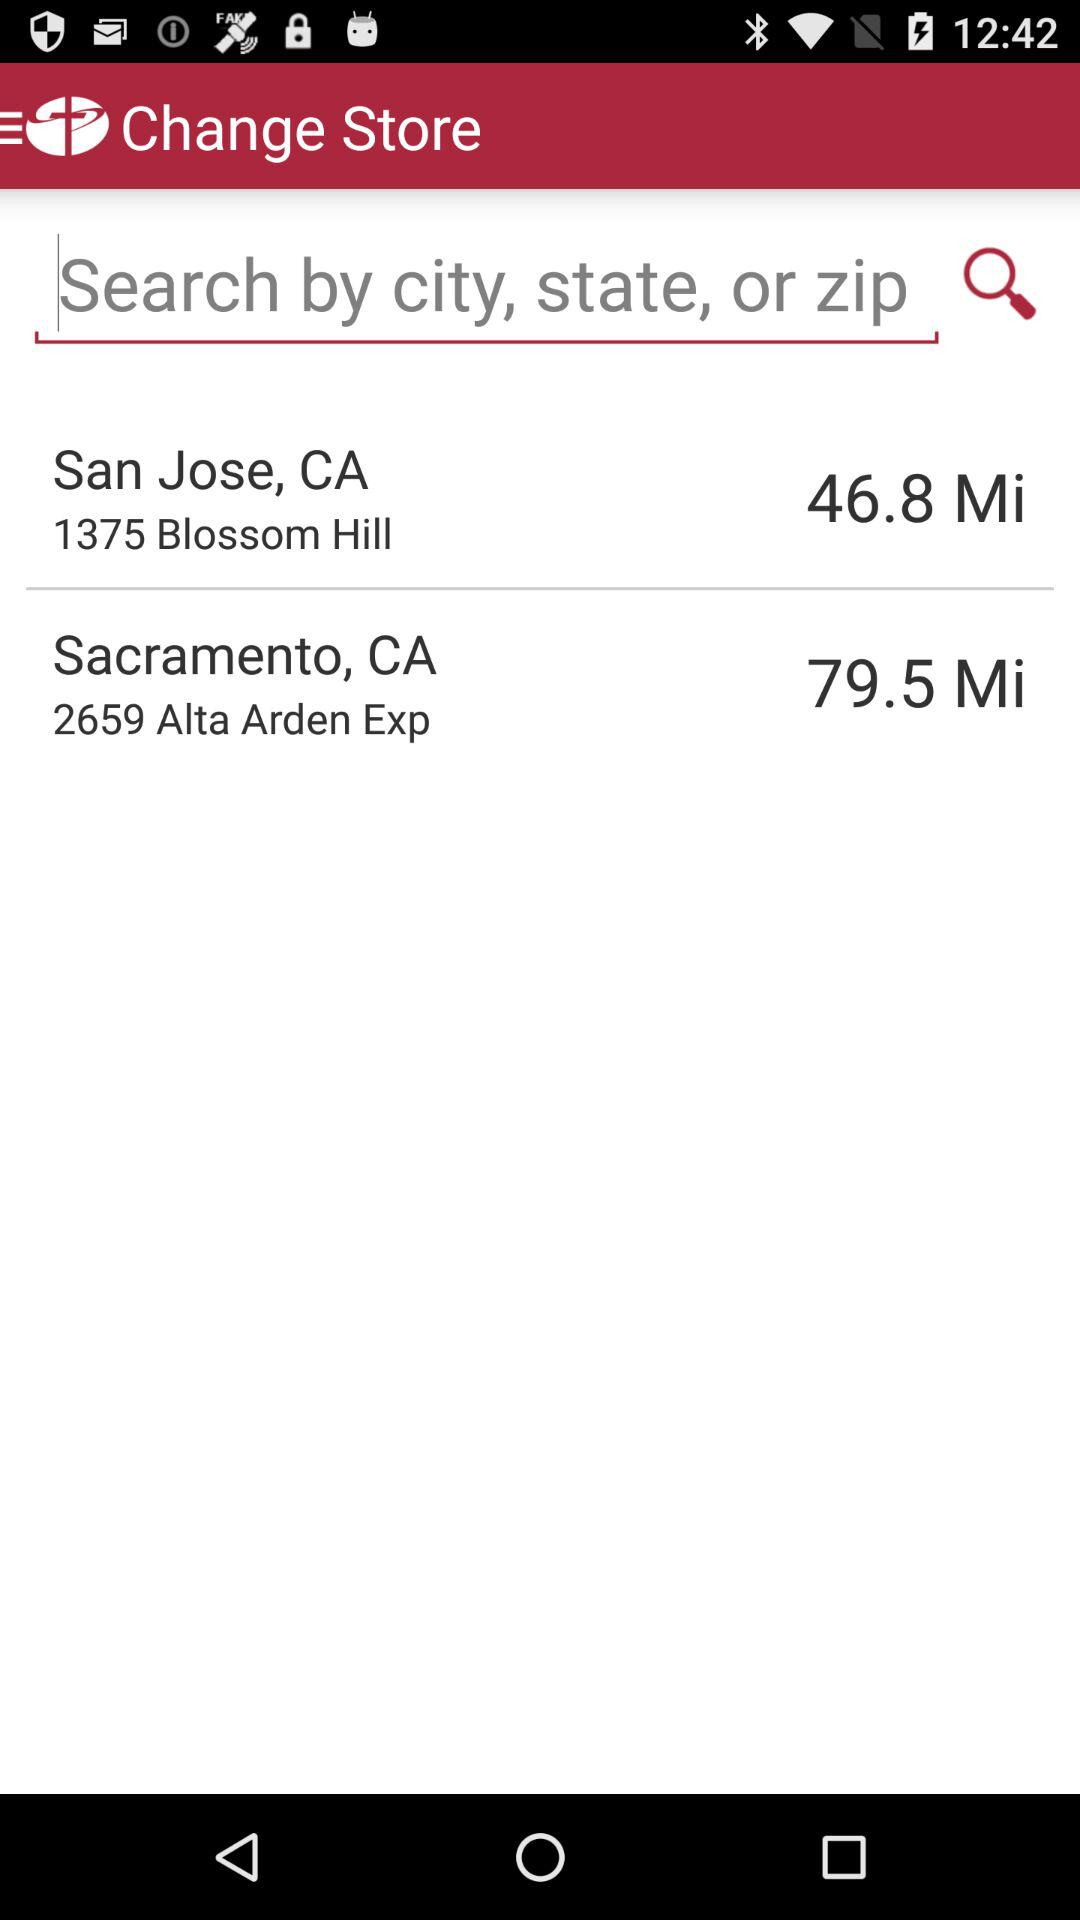What is the address of the store in San Jose, CA? The address of the store is 1375 Blossom Hill. 